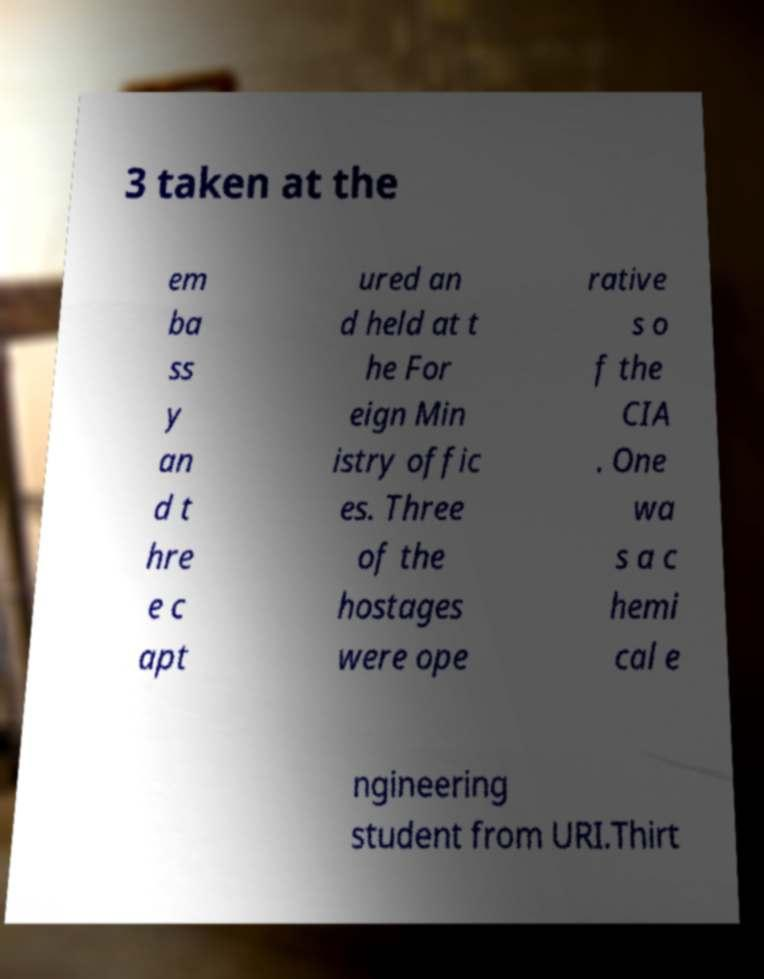Can you accurately transcribe the text from the provided image for me? 3 taken at the em ba ss y an d t hre e c apt ured an d held at t he For eign Min istry offic es. Three of the hostages were ope rative s o f the CIA . One wa s a c hemi cal e ngineering student from URI.Thirt 